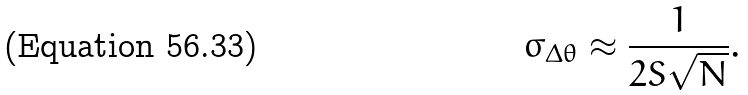Convert formula to latex. <formula><loc_0><loc_0><loc_500><loc_500>\sigma _ { \Delta \theta } \approx \frac { 1 } { 2 S \sqrt { N } } .</formula> 